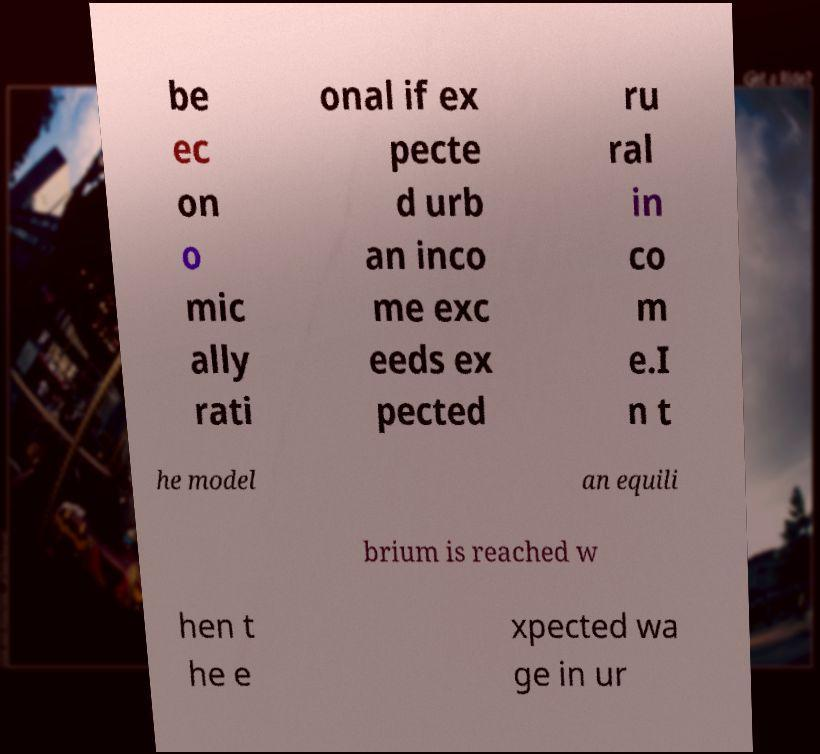Can you accurately transcribe the text from the provided image for me? be ec on o mic ally rati onal if ex pecte d urb an inco me exc eeds ex pected ru ral in co m e.I n t he model an equili brium is reached w hen t he e xpected wa ge in ur 